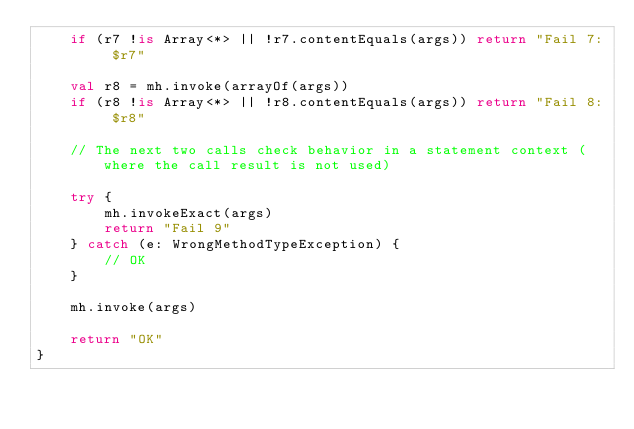<code> <loc_0><loc_0><loc_500><loc_500><_Kotlin_>    if (r7 !is Array<*> || !r7.contentEquals(args)) return "Fail 7: $r7"

    val r8 = mh.invoke(arrayOf(args))
    if (r8 !is Array<*> || !r8.contentEquals(args)) return "Fail 8: $r8"

    // The next two calls check behavior in a statement context (where the call result is not used)

    try {
        mh.invokeExact(args)
        return "Fail 9"
    } catch (e: WrongMethodTypeException) {
        // OK
    }

    mh.invoke(args)

    return "OK"
}
</code> 